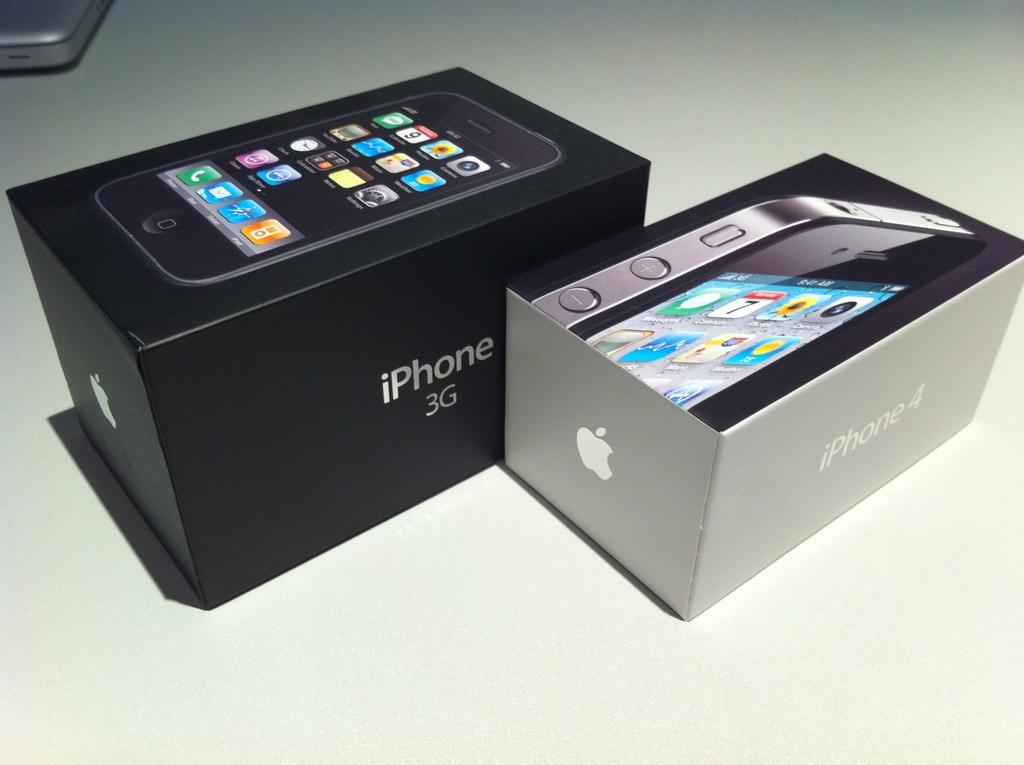<image>
Provide a brief description of the given image. An iPhone 3G phone that is shown in it's original packaging. 